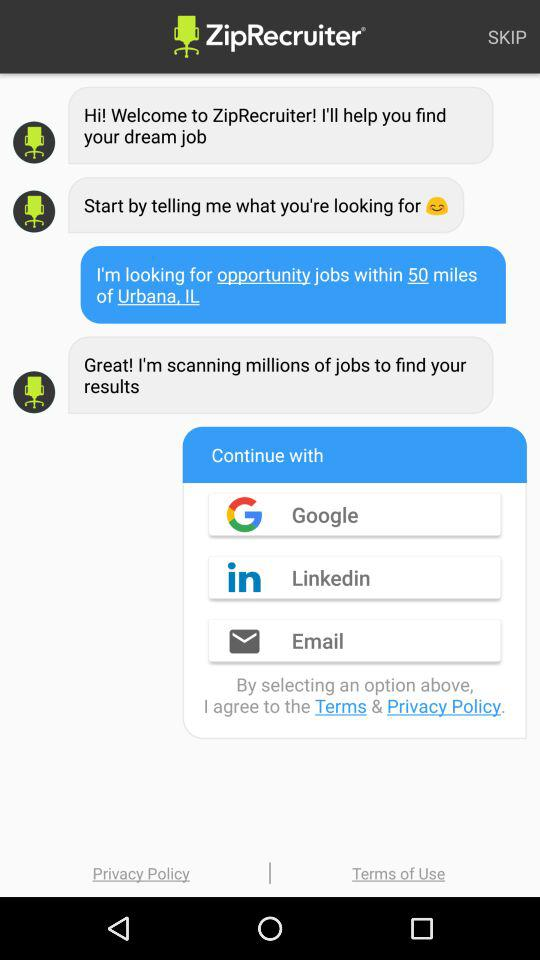How do I access Zip Recruiter?
When the provided information is insufficient, respond with <no answer>. <no answer> 